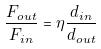Convert formula to latex. <formula><loc_0><loc_0><loc_500><loc_500>\frac { F _ { o u t } } { F _ { i n } } = \eta \frac { d _ { i n } } { d _ { o u t } }</formula> 